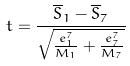<formula> <loc_0><loc_0><loc_500><loc_500>t = \frac { \overline { S } _ { 1 } - \overline { S } _ { 7 } } { \sqrt { \frac { e _ { 1 } ^ { 7 } } { M _ { 1 } } + \frac { e _ { 7 } ^ { 7 } } { M _ { 7 } } } }</formula> 